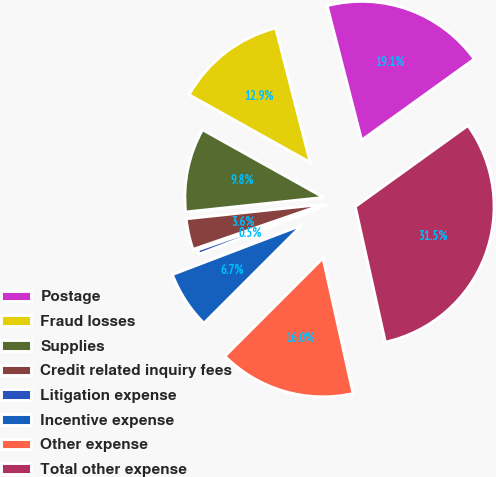<chart> <loc_0><loc_0><loc_500><loc_500><pie_chart><fcel>Postage<fcel>Fraud losses<fcel>Supplies<fcel>Credit related inquiry fees<fcel>Litigation expense<fcel>Incentive expense<fcel>Other expense<fcel>Total other expense<nl><fcel>19.07%<fcel>12.89%<fcel>9.79%<fcel>3.61%<fcel>0.51%<fcel>6.7%<fcel>15.98%<fcel>31.45%<nl></chart> 